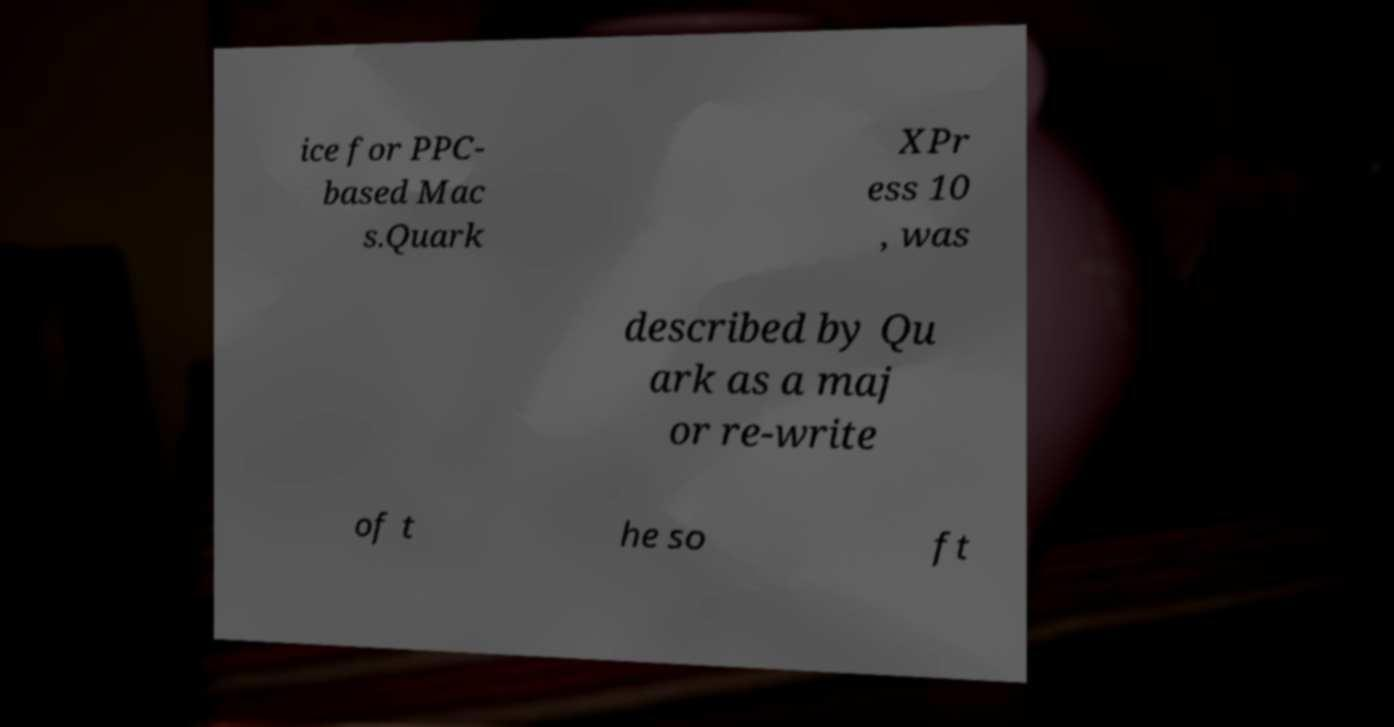I need the written content from this picture converted into text. Can you do that? ice for PPC- based Mac s.Quark XPr ess 10 , was described by Qu ark as a maj or re-write of t he so ft 